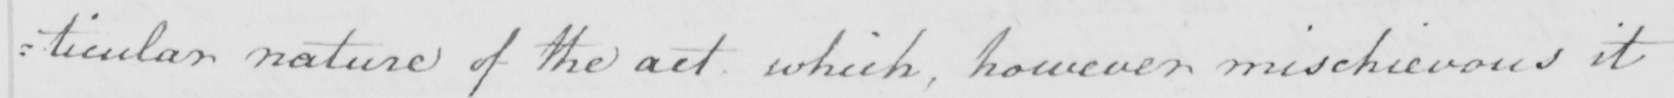Can you tell me what this handwritten text says? : ticular nature of the act which , however mischievous it 